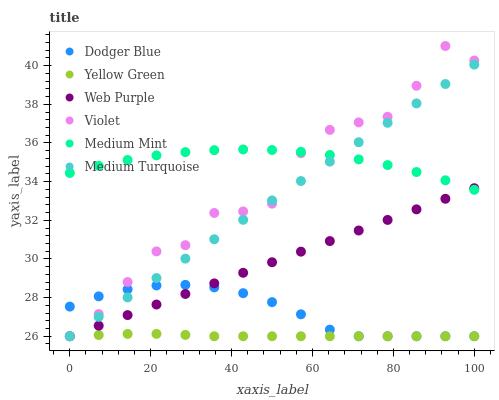Does Yellow Green have the minimum area under the curve?
Answer yes or no. Yes. Does Medium Mint have the maximum area under the curve?
Answer yes or no. Yes. Does Web Purple have the minimum area under the curve?
Answer yes or no. No. Does Web Purple have the maximum area under the curve?
Answer yes or no. No. Is Web Purple the smoothest?
Answer yes or no. Yes. Is Violet the roughest?
Answer yes or no. Yes. Is Yellow Green the smoothest?
Answer yes or no. No. Is Yellow Green the roughest?
Answer yes or no. No. Does Yellow Green have the lowest value?
Answer yes or no. Yes. Does Violet have the highest value?
Answer yes or no. Yes. Does Web Purple have the highest value?
Answer yes or no. No. Is Dodger Blue less than Medium Mint?
Answer yes or no. Yes. Is Medium Mint greater than Yellow Green?
Answer yes or no. Yes. Does Violet intersect Dodger Blue?
Answer yes or no. Yes. Is Violet less than Dodger Blue?
Answer yes or no. No. Is Violet greater than Dodger Blue?
Answer yes or no. No. Does Dodger Blue intersect Medium Mint?
Answer yes or no. No. 